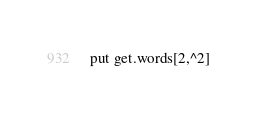Convert code to text. <code><loc_0><loc_0><loc_500><loc_500><_Perl_>put get.words[2,^2]</code> 